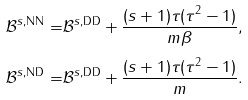Convert formula to latex. <formula><loc_0><loc_0><loc_500><loc_500>\mathcal { B } ^ { s , \text {NN} } = & \mathcal { B } ^ { s , \text {DD} } + \frac { ( s + 1 ) \tau ( \tau ^ { 2 } - 1 ) } { m \beta } , \\ \mathcal { B } ^ { s , \text {ND} } = & \mathcal { B } ^ { s , \text {DD} } + \frac { ( s + 1 ) \tau ( \tau ^ { 2 } - 1 ) } { m } .</formula> 